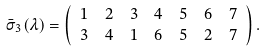Convert formula to latex. <formula><loc_0><loc_0><loc_500><loc_500>\bar { \sigma } _ { 3 } ( \lambda ) & = \left ( \begin{array} { c c c c c c c } 1 & 2 & 3 & 4 & 5 & 6 & 7 \\ 3 & 4 & 1 & 6 & 5 & 2 & 7 \end{array} \right ) .</formula> 